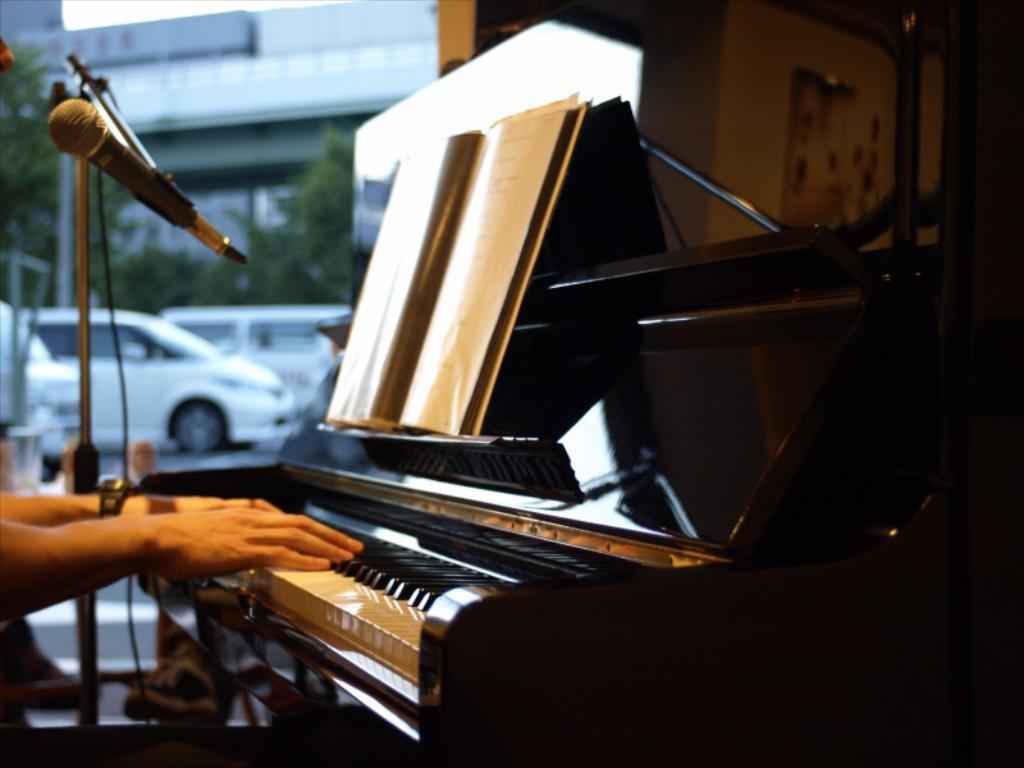What is the person in the image doing? The person is playing piano in the image. What object is present for amplifying sound or assisting in a performance? There is a microphone (mike) in the image. What item can be seen that is typically used for reading or learning? There is a book in the image. What can be seen moving on the road in the image? Vehicles are visible on the road in the image. What type of vegetation is present in the image? There are trees in the image. What type of structure is visible in the image? There is a building in the image. What page is the person's brother turning in the image? There is no page or brother present in the image; it features a person playing piano, a microphone, a book, vehicles, trees, and a building. What type of tool is the person using to fix the wrench in the image? There is no wrench or tool present in the image; it features a person playing piano, a microphone, a book, vehicles, trees, and a building. 